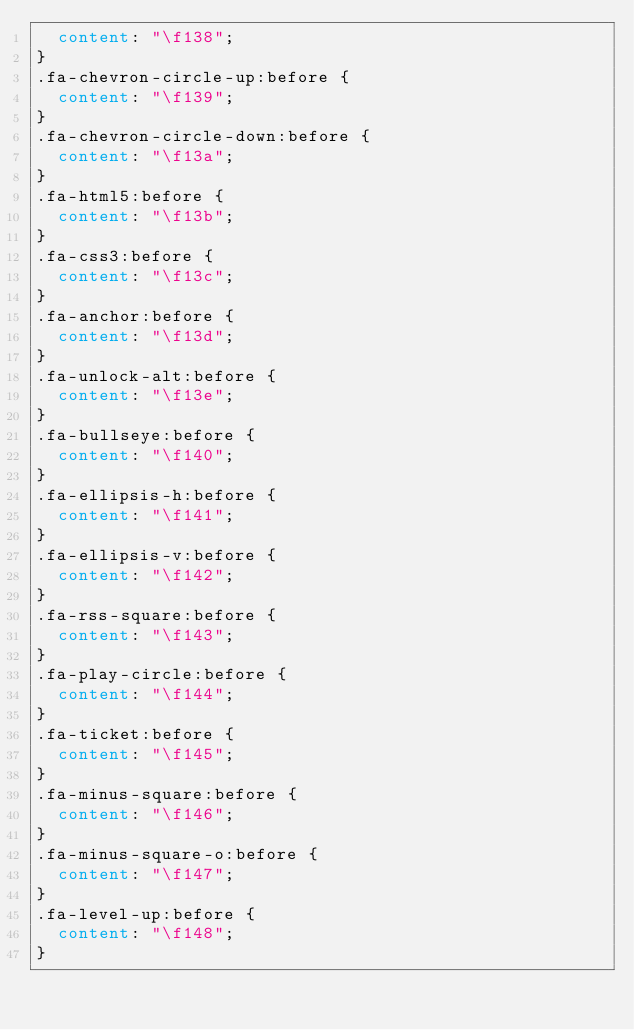Convert code to text. <code><loc_0><loc_0><loc_500><loc_500><_CSS_>  content: "\f138";
}
.fa-chevron-circle-up:before {
  content: "\f139";
}
.fa-chevron-circle-down:before {
  content: "\f13a";
}
.fa-html5:before {
  content: "\f13b";
}
.fa-css3:before {
  content: "\f13c";
}
.fa-anchor:before {
  content: "\f13d";
}
.fa-unlock-alt:before {
  content: "\f13e";
}
.fa-bullseye:before {
  content: "\f140";
}
.fa-ellipsis-h:before {
  content: "\f141";
}
.fa-ellipsis-v:before {
  content: "\f142";
}
.fa-rss-square:before {
  content: "\f143";
}
.fa-play-circle:before {
  content: "\f144";
}
.fa-ticket:before {
  content: "\f145";
}
.fa-minus-square:before {
  content: "\f146";
}
.fa-minus-square-o:before {
  content: "\f147";
}
.fa-level-up:before {
  content: "\f148";
}</code> 